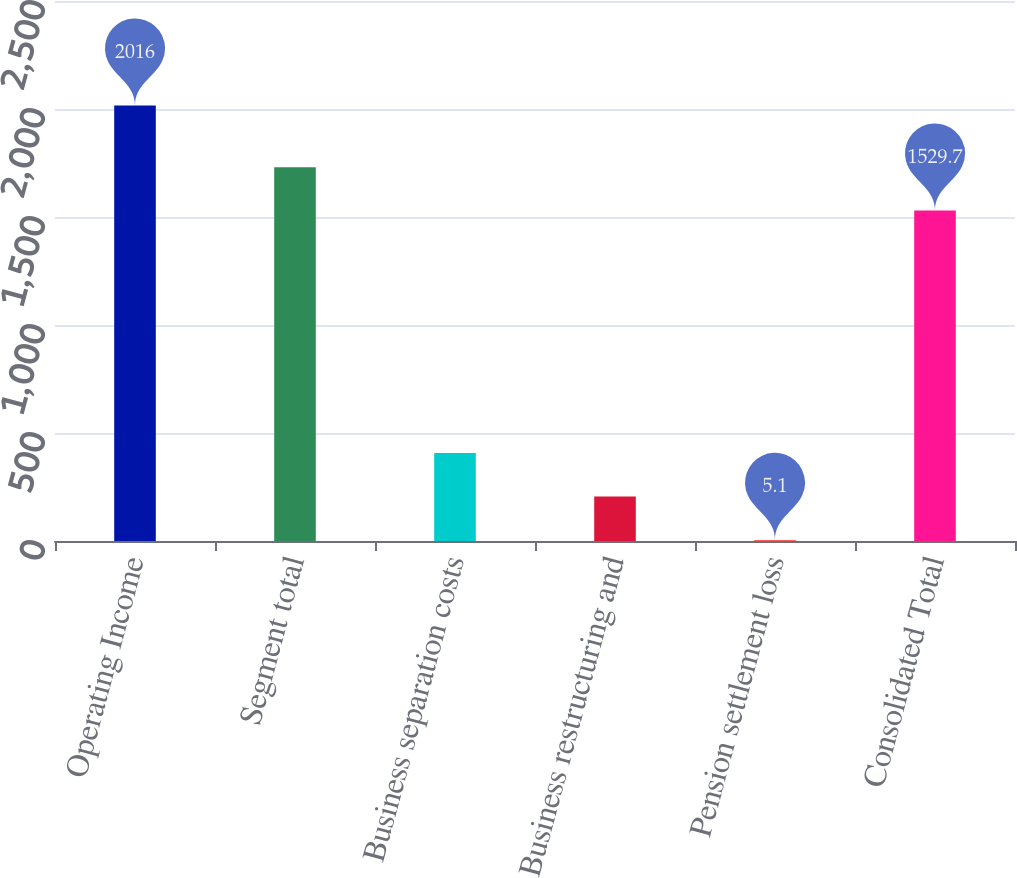<chart> <loc_0><loc_0><loc_500><loc_500><bar_chart><fcel>Operating Income<fcel>Segment total<fcel>Business separation costs<fcel>Business restructuring and<fcel>Pension settlement loss<fcel>Consolidated Total<nl><fcel>2016<fcel>1730.79<fcel>407.28<fcel>206.19<fcel>5.1<fcel>1529.7<nl></chart> 